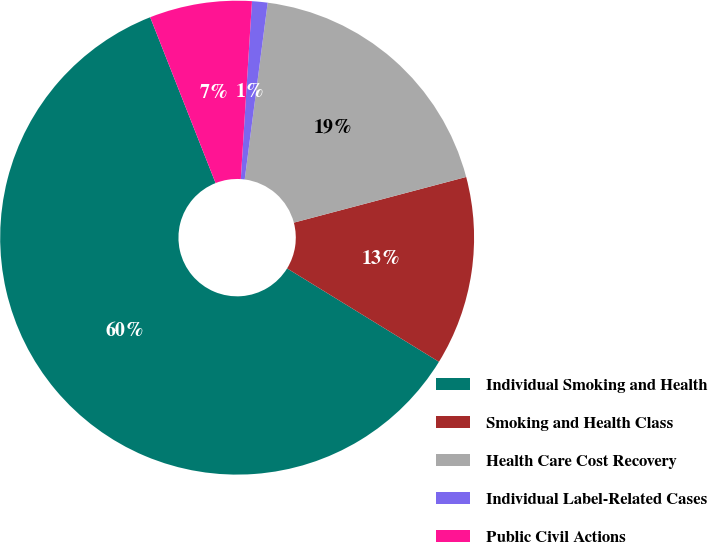<chart> <loc_0><loc_0><loc_500><loc_500><pie_chart><fcel>Individual Smoking and Health<fcel>Smoking and Health Class<fcel>Health Care Cost Recovery<fcel>Individual Label-Related Cases<fcel>Public Civil Actions<nl><fcel>60.25%<fcel>12.9%<fcel>18.82%<fcel>1.06%<fcel>6.98%<nl></chart> 